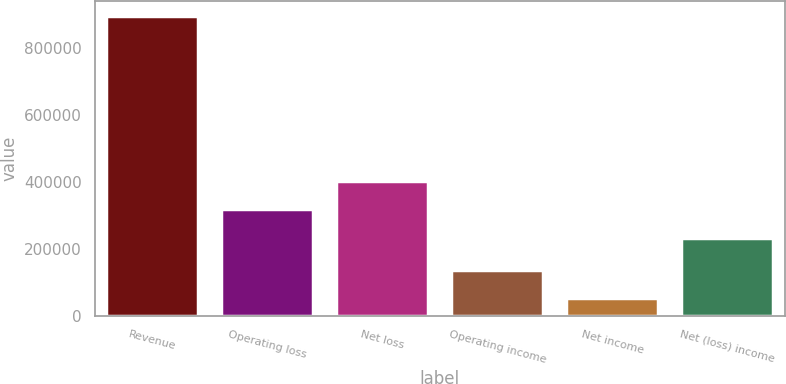<chart> <loc_0><loc_0><loc_500><loc_500><bar_chart><fcel>Revenue<fcel>Operating loss<fcel>Net loss<fcel>Operating income<fcel>Net income<fcel>Net (loss) income<nl><fcel>894725<fcel>318232<fcel>402257<fcel>138494<fcel>54468<fcel>234206<nl></chart> 